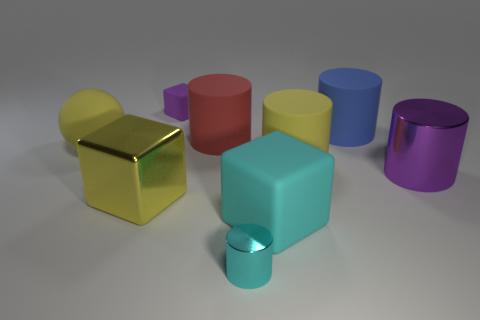Does the tiny cylinder have the same color as the big rubber block?
Give a very brief answer. Yes. Does the purple matte object have the same shape as the cyan thing that is to the right of the small cyan metal object?
Make the answer very short. Yes. Are there more yellow rubber balls than tiny green metallic objects?
Provide a short and direct response. Yes. Is there any other thing that has the same size as the purple cylinder?
Give a very brief answer. Yes. Is the shape of the metallic object on the right side of the small cylinder the same as  the blue thing?
Your response must be concise. Yes. Is the number of small purple objects that are in front of the tiny cyan shiny cylinder greater than the number of large purple cylinders?
Your answer should be very brief. No. There is a rubber cube that is behind the large yellow rubber object that is to the right of the large cyan rubber block; what color is it?
Offer a terse response. Purple. What number of big purple metal cylinders are there?
Offer a terse response. 1. How many things are both on the right side of the tiny purple thing and in front of the yellow rubber cylinder?
Ensure brevity in your answer.  3. Are there any other things that are the same shape as the tiny purple thing?
Offer a very short reply. Yes. 